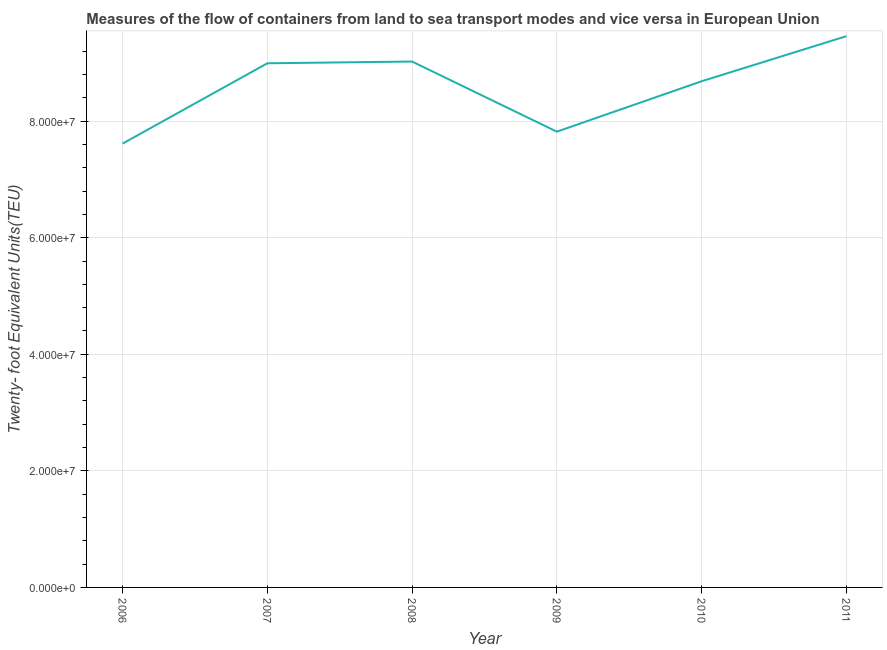What is the container port traffic in 2009?
Offer a very short reply. 7.82e+07. Across all years, what is the maximum container port traffic?
Your answer should be compact. 9.46e+07. Across all years, what is the minimum container port traffic?
Offer a terse response. 7.61e+07. In which year was the container port traffic minimum?
Offer a very short reply. 2006. What is the sum of the container port traffic?
Offer a terse response. 5.16e+08. What is the difference between the container port traffic in 2006 and 2008?
Provide a short and direct response. -1.41e+07. What is the average container port traffic per year?
Offer a terse response. 8.60e+07. What is the median container port traffic?
Your answer should be compact. 8.84e+07. What is the ratio of the container port traffic in 2009 to that in 2011?
Ensure brevity in your answer.  0.83. Is the container port traffic in 2008 less than that in 2011?
Keep it short and to the point. Yes. What is the difference between the highest and the second highest container port traffic?
Your response must be concise. 4.35e+06. Is the sum of the container port traffic in 2008 and 2009 greater than the maximum container port traffic across all years?
Your answer should be very brief. Yes. What is the difference between the highest and the lowest container port traffic?
Make the answer very short. 1.84e+07. Does the container port traffic monotonically increase over the years?
Offer a terse response. No. How many years are there in the graph?
Provide a succinct answer. 6. What is the difference between two consecutive major ticks on the Y-axis?
Give a very brief answer. 2.00e+07. Does the graph contain any zero values?
Give a very brief answer. No. What is the title of the graph?
Offer a very short reply. Measures of the flow of containers from land to sea transport modes and vice versa in European Union. What is the label or title of the Y-axis?
Your answer should be very brief. Twenty- foot Equivalent Units(TEU). What is the Twenty- foot Equivalent Units(TEU) in 2006?
Keep it short and to the point. 7.61e+07. What is the Twenty- foot Equivalent Units(TEU) of 2007?
Keep it short and to the point. 8.99e+07. What is the Twenty- foot Equivalent Units(TEU) of 2008?
Keep it short and to the point. 9.02e+07. What is the Twenty- foot Equivalent Units(TEU) in 2009?
Offer a very short reply. 7.82e+07. What is the Twenty- foot Equivalent Units(TEU) of 2010?
Offer a terse response. 8.68e+07. What is the Twenty- foot Equivalent Units(TEU) of 2011?
Make the answer very short. 9.46e+07. What is the difference between the Twenty- foot Equivalent Units(TEU) in 2006 and 2007?
Provide a short and direct response. -1.38e+07. What is the difference between the Twenty- foot Equivalent Units(TEU) in 2006 and 2008?
Make the answer very short. -1.41e+07. What is the difference between the Twenty- foot Equivalent Units(TEU) in 2006 and 2009?
Give a very brief answer. -2.05e+06. What is the difference between the Twenty- foot Equivalent Units(TEU) in 2006 and 2010?
Your answer should be very brief. -1.07e+07. What is the difference between the Twenty- foot Equivalent Units(TEU) in 2006 and 2011?
Give a very brief answer. -1.84e+07. What is the difference between the Twenty- foot Equivalent Units(TEU) in 2007 and 2008?
Your answer should be compact. -2.98e+05. What is the difference between the Twenty- foot Equivalent Units(TEU) in 2007 and 2009?
Offer a very short reply. 1.17e+07. What is the difference between the Twenty- foot Equivalent Units(TEU) in 2007 and 2010?
Offer a very short reply. 3.09e+06. What is the difference between the Twenty- foot Equivalent Units(TEU) in 2007 and 2011?
Your answer should be compact. -4.65e+06. What is the difference between the Twenty- foot Equivalent Units(TEU) in 2008 and 2009?
Give a very brief answer. 1.20e+07. What is the difference between the Twenty- foot Equivalent Units(TEU) in 2008 and 2010?
Your response must be concise. 3.38e+06. What is the difference between the Twenty- foot Equivalent Units(TEU) in 2008 and 2011?
Make the answer very short. -4.35e+06. What is the difference between the Twenty- foot Equivalent Units(TEU) in 2009 and 2010?
Provide a succinct answer. -8.65e+06. What is the difference between the Twenty- foot Equivalent Units(TEU) in 2009 and 2011?
Give a very brief answer. -1.64e+07. What is the difference between the Twenty- foot Equivalent Units(TEU) in 2010 and 2011?
Your answer should be very brief. -7.73e+06. What is the ratio of the Twenty- foot Equivalent Units(TEU) in 2006 to that in 2007?
Give a very brief answer. 0.85. What is the ratio of the Twenty- foot Equivalent Units(TEU) in 2006 to that in 2008?
Ensure brevity in your answer.  0.84. What is the ratio of the Twenty- foot Equivalent Units(TEU) in 2006 to that in 2009?
Provide a short and direct response. 0.97. What is the ratio of the Twenty- foot Equivalent Units(TEU) in 2006 to that in 2010?
Your answer should be very brief. 0.88. What is the ratio of the Twenty- foot Equivalent Units(TEU) in 2006 to that in 2011?
Your response must be concise. 0.81. What is the ratio of the Twenty- foot Equivalent Units(TEU) in 2007 to that in 2008?
Your response must be concise. 1. What is the ratio of the Twenty- foot Equivalent Units(TEU) in 2007 to that in 2009?
Offer a terse response. 1.15. What is the ratio of the Twenty- foot Equivalent Units(TEU) in 2007 to that in 2010?
Offer a very short reply. 1.04. What is the ratio of the Twenty- foot Equivalent Units(TEU) in 2007 to that in 2011?
Offer a very short reply. 0.95. What is the ratio of the Twenty- foot Equivalent Units(TEU) in 2008 to that in 2009?
Make the answer very short. 1.15. What is the ratio of the Twenty- foot Equivalent Units(TEU) in 2008 to that in 2010?
Provide a short and direct response. 1.04. What is the ratio of the Twenty- foot Equivalent Units(TEU) in 2008 to that in 2011?
Keep it short and to the point. 0.95. What is the ratio of the Twenty- foot Equivalent Units(TEU) in 2009 to that in 2010?
Your response must be concise. 0.9. What is the ratio of the Twenty- foot Equivalent Units(TEU) in 2009 to that in 2011?
Your response must be concise. 0.83. What is the ratio of the Twenty- foot Equivalent Units(TEU) in 2010 to that in 2011?
Provide a succinct answer. 0.92. 